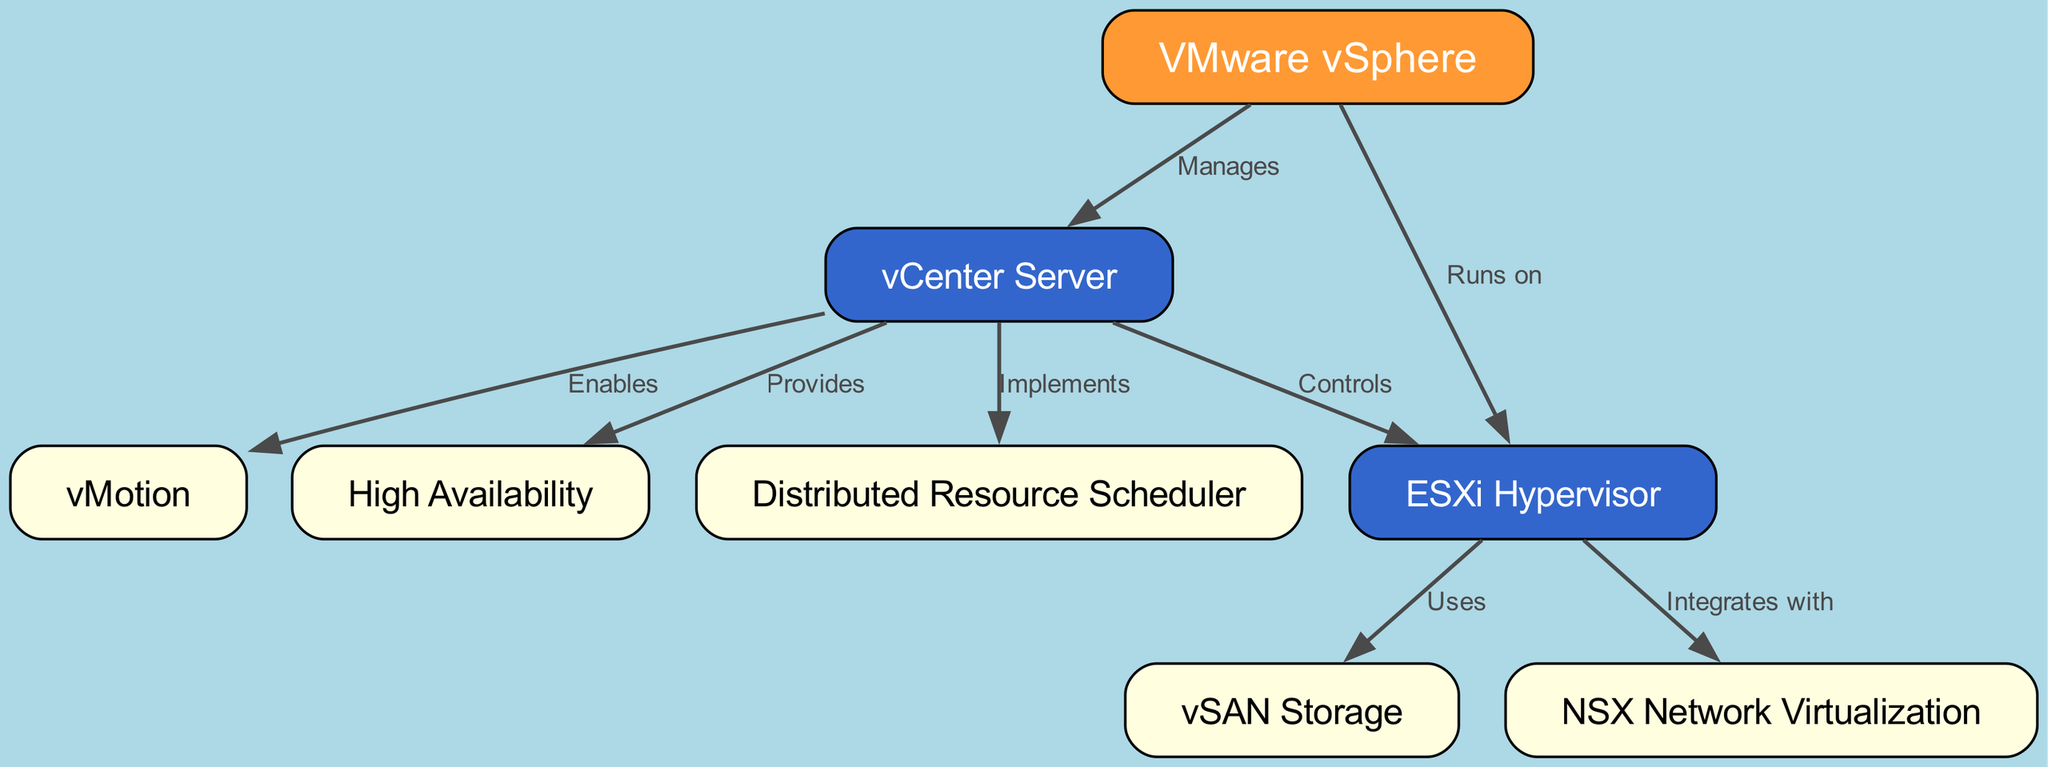What is the main component represented at the top of the diagram? The topmost node in the diagram is labeled "VMware vSphere," indicating that it is the main component from which other elements derive their function and purpose.
Answer: VMware vSphere How many nodes are present in the diagram? By counting each distinct component represented in the diagram, there are a total of 8 nodes: VMware vSphere, vCenter Server, ESXi Hypervisor, vSAN Storage, NSX Network Virtualization, vMotion, High Availability, and Distributed Resource Scheduler.
Answer: 8 What relationship does vCenter Server have with ESXi Hypervisor? The diagram shows an edge connecting "vCenter Server" to "ESXi Hypervisor" with the label "Controls," indicating that the vCenter Server oversees the operations of the ESXi Hypervisor.
Answer: Controls Which component is used by ESXi according to the diagram? The edge labeled "Uses" points from "ESXi Hypervisor" to "vSAN Storage," indicating that the ESXi Hypervisor utilizes vSAN for storage solutions.
Answer: vSAN Storage What feature does vCenter Server enable according to the diagram? The edge labeled "Enables" leads from "vCenter Server" to "vMotion," indicating that vCenter Server provides the functionality for vMotion, which is the live migration of virtual machines between hosts.
Answer: vMotion How many relationships does vCenter Server have in the diagram? Counting the outgoing edges from "vCenter Server," there are four relationships: it controls ESXi, enables vMotion, provides High Availability, and implements Distributed Resource Scheduler.
Answer: 4 What does ESXi integrate with based on the diagram? According to the diagram, the edge labeled "Integrates with" links "ESXi Hypervisor" and "NSX Network Virtualization," indicating that ESXi integrates with NSX for network functions.
Answer: NSX Network Virtualization What is the role of the Distributed Resource Scheduler in the context of vCenter Server? The diagram indicates that vCenter Server "Implements" the Distributed Resource Scheduler, which manages the distribution of resources across multiple ESXi hosts for optimal performance and efficiency.
Answer: Implements 